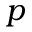<formula> <loc_0><loc_0><loc_500><loc_500>p</formula> 